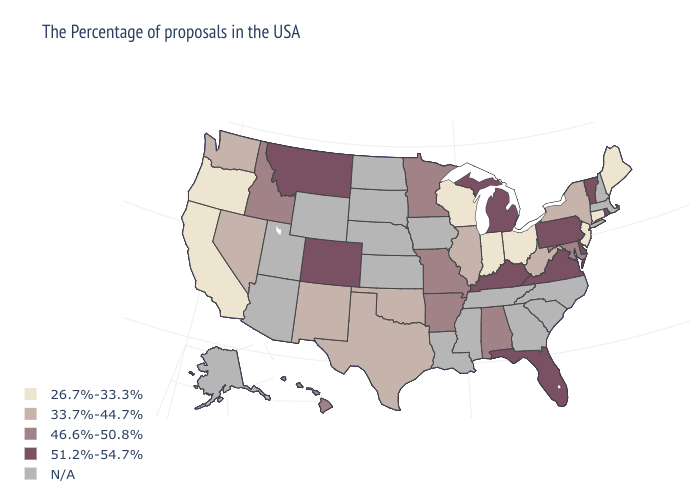Name the states that have a value in the range 33.7%-44.7%?
Answer briefly. New York, West Virginia, Illinois, Oklahoma, Texas, New Mexico, Nevada, Washington. What is the value of New Mexico?
Concise answer only. 33.7%-44.7%. What is the value of Arkansas?
Keep it brief. 46.6%-50.8%. What is the highest value in states that border Kansas?
Concise answer only. 51.2%-54.7%. What is the value of Oregon?
Short answer required. 26.7%-33.3%. Does Oregon have the lowest value in the West?
Write a very short answer. Yes. Which states have the lowest value in the USA?
Write a very short answer. Maine, Connecticut, New Jersey, Ohio, Indiana, Wisconsin, California, Oregon. Name the states that have a value in the range N/A?
Quick response, please. Massachusetts, New Hampshire, North Carolina, South Carolina, Georgia, Tennessee, Mississippi, Louisiana, Iowa, Kansas, Nebraska, South Dakota, North Dakota, Wyoming, Utah, Arizona, Alaska. Which states have the lowest value in the West?
Answer briefly. California, Oregon. What is the value of Kentucky?
Keep it brief. 51.2%-54.7%. Among the states that border Texas , does New Mexico have the lowest value?
Answer briefly. Yes. Does Oregon have the lowest value in the USA?
Concise answer only. Yes. What is the value of Wyoming?
Write a very short answer. N/A. 